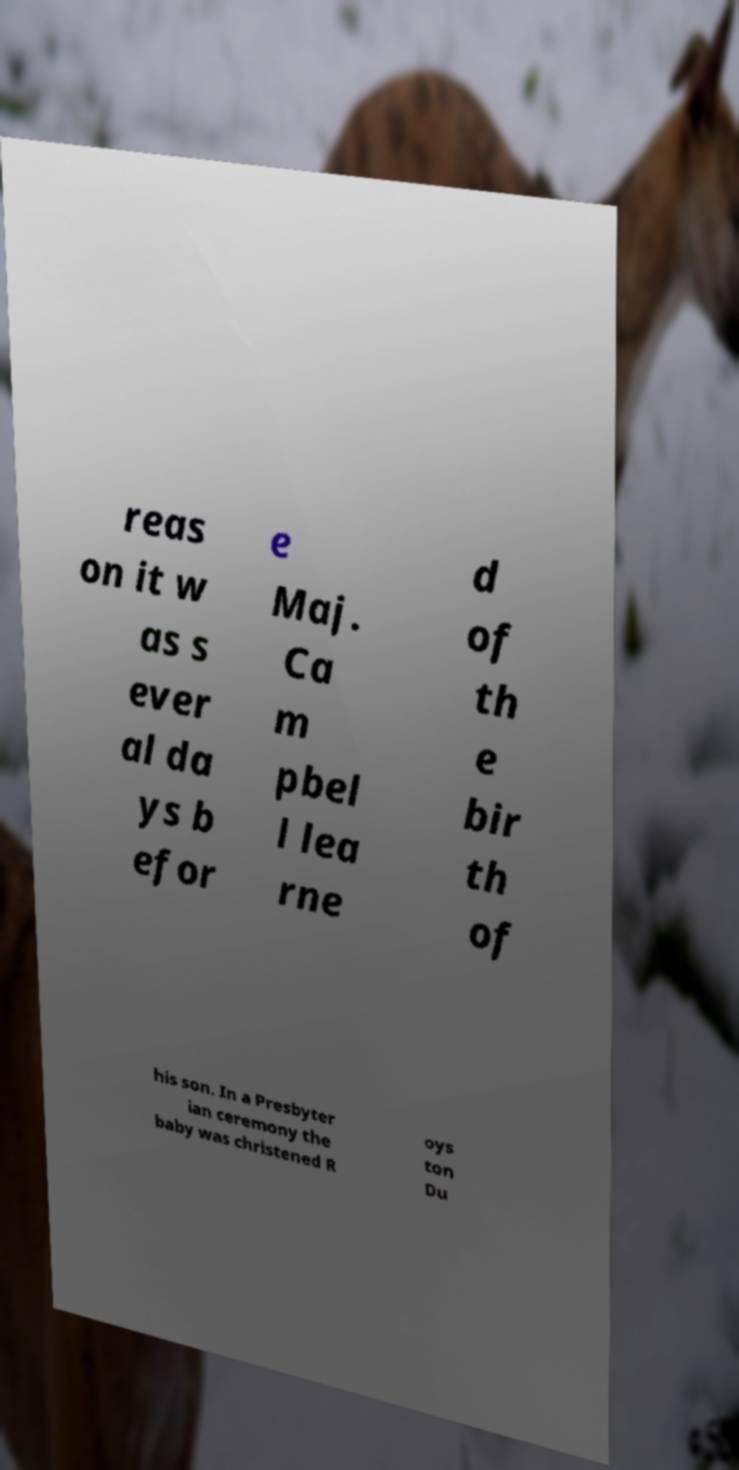Could you assist in decoding the text presented in this image and type it out clearly? reas on it w as s ever al da ys b efor e Maj. Ca m pbel l lea rne d of th e bir th of his son. In a Presbyter ian ceremony the baby was christened R oys ton Du 